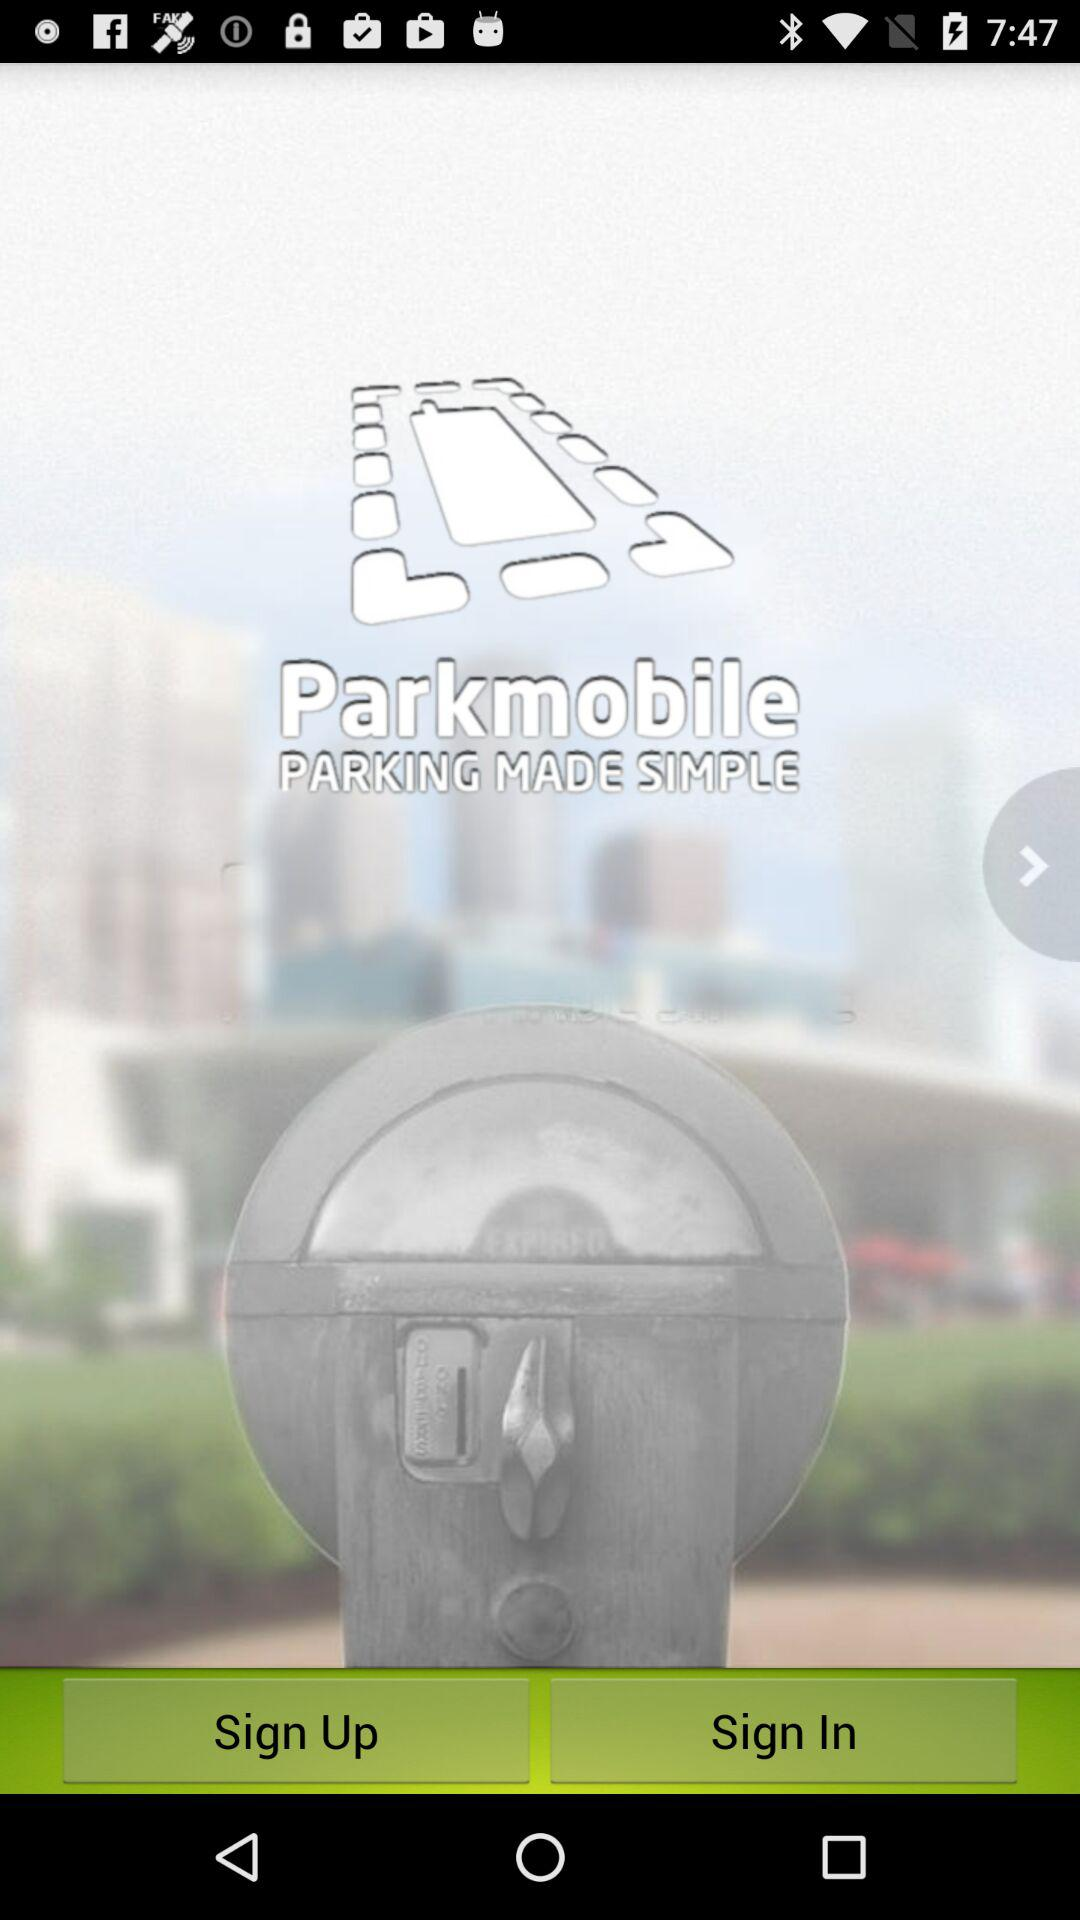What is the app name? The app name is "Parkmobile". 